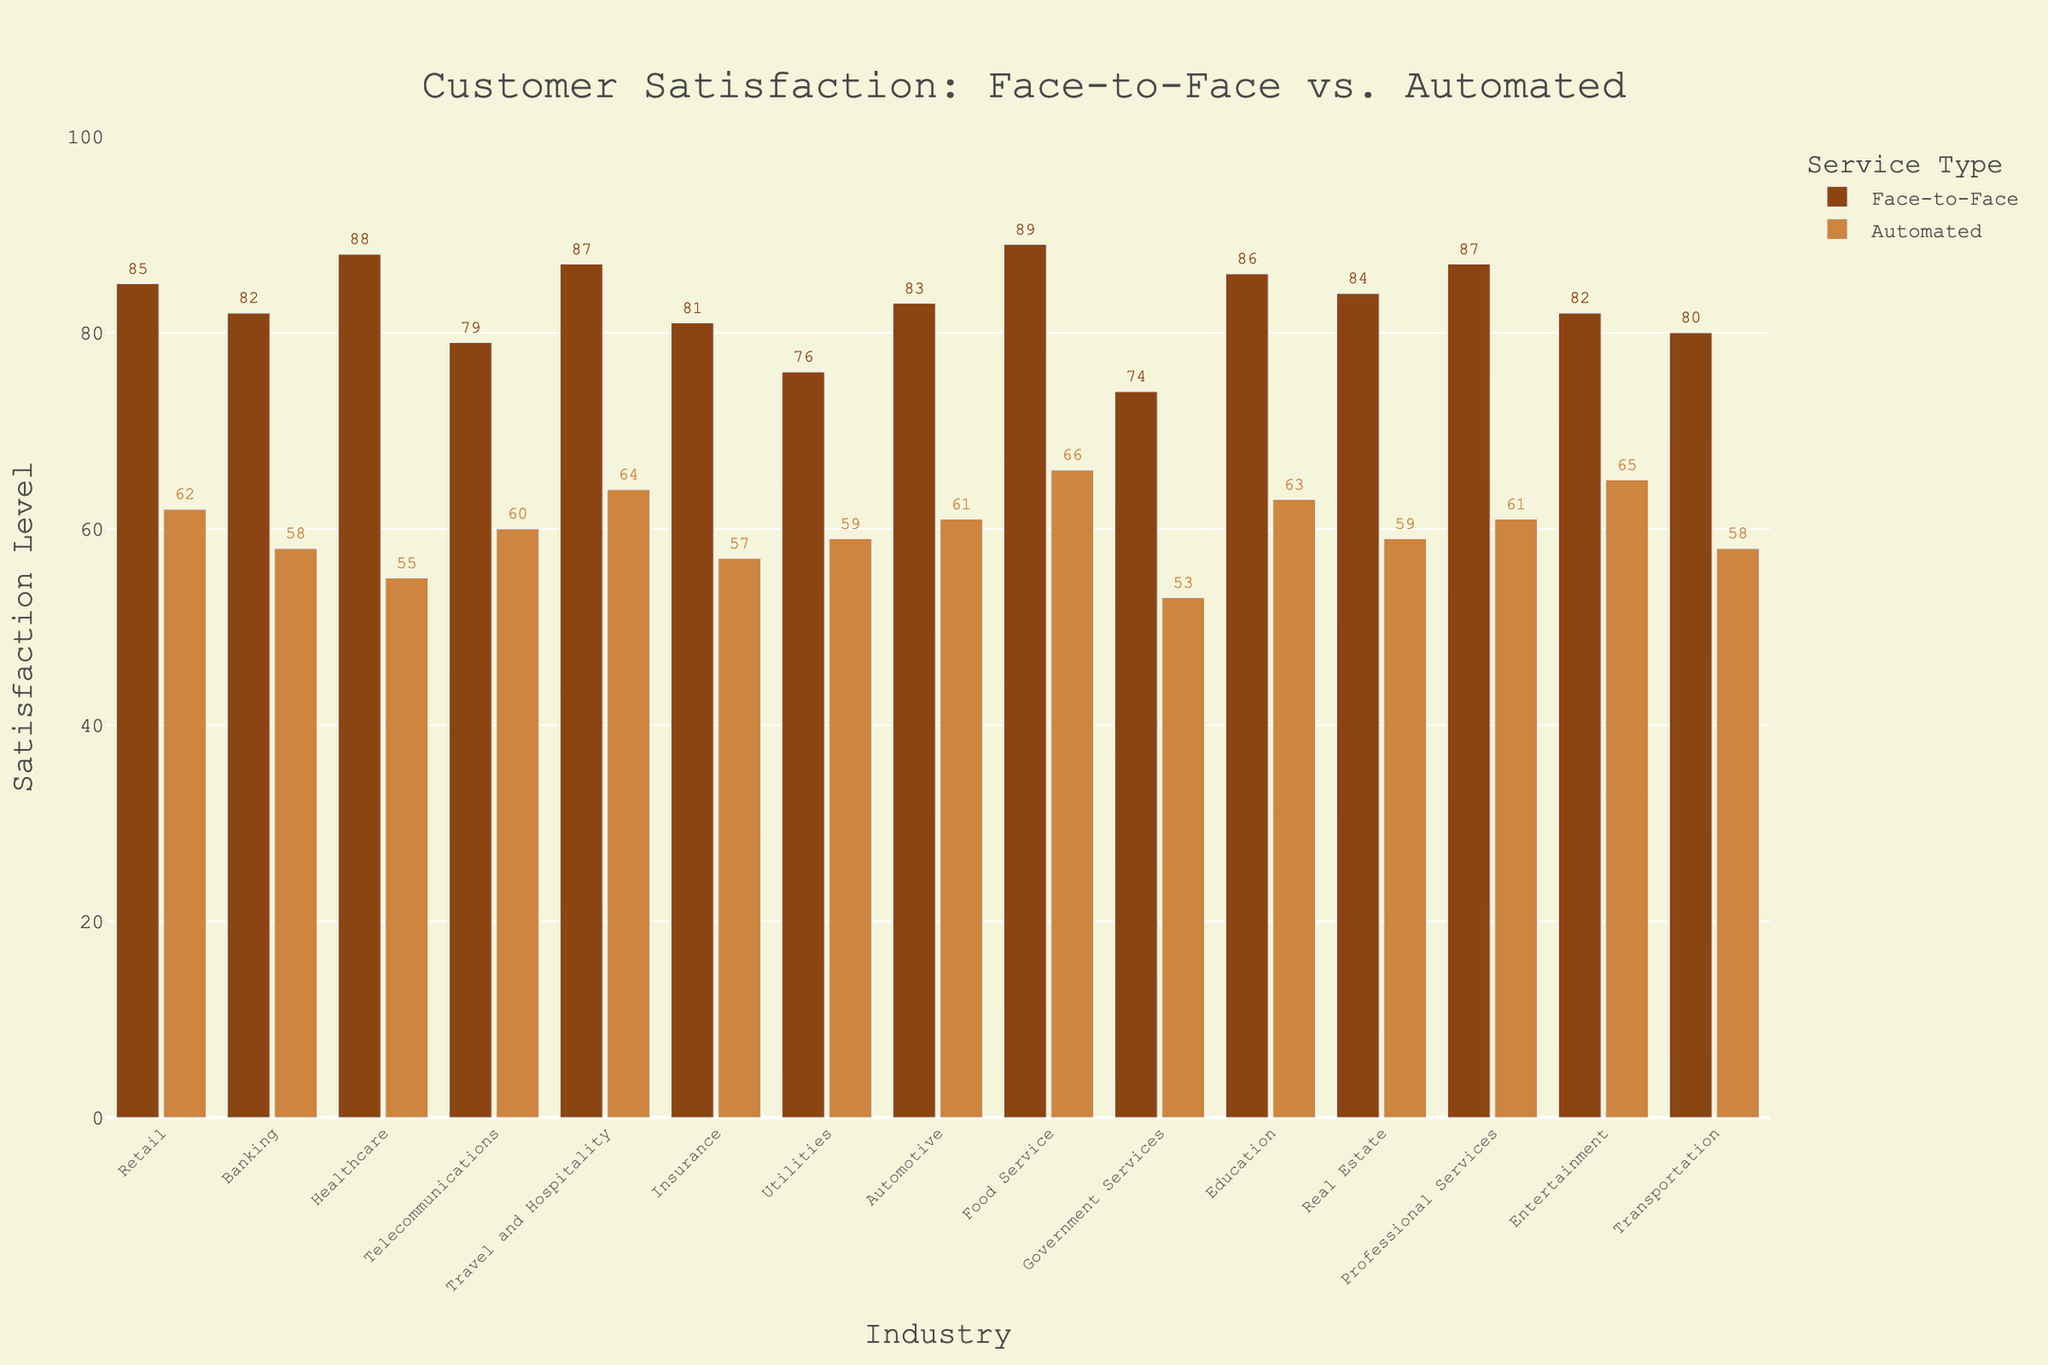Which industry has the highest face-to-face satisfaction level? The tallest bar in the face-to-face category represents the industry with the highest satisfaction level. The food service industry has the highest face-to-face satisfaction level at 89.
Answer: Food Service Which industry has the lowest automated satisfaction level? The shortest bar in the automated category represents the industry with the lowest satisfaction level. The government services industry has the lowest automated satisfaction level at 53.
Answer: Government Services What is the difference in satisfaction level between face-to-face and automated services for the healthcare industry? For healthcare, subtract the automated satisfaction value (55) from the face-to-face satisfaction value (88). 88 - 55 = 33.
Answer: 33 Which industry shows the smallest gap between face-to-face and automated satisfaction levels? Find the bars with the smallest visual difference in height between face-to-face and automated categories. The retail industry has a difference of only 23 points (85 - 62).
Answer: Retail Calculate the average face-to-face satisfaction across all industries represented in the chart. Add up all the face-to-face satisfaction values and divide by the number of industries: (85 + 82 + 88 + 79 + 87 + 81 + 76 + 83 + 89 + 74 + 86 + 84 + 87 + 82 + 80) / 15. This totals 1223 / 15 = 81.53.
Answer: 81.53 Which industry has a higher satisfaction level for automated services compared to its face-to-face services? Look for any industry where the automated bar is taller than the face-to-face bar. In this chart, no industry has higher automated satisfaction levels compared to face-to-face levels.
Answer: None What is the total satisfaction level combining both face-to-face and automated for the travel and hospitality industry? Sum the face-to-face satisfaction level (87) with the automated satisfaction level (64). 87 + 64 = 151.
Answer: 151 Identify the industry with the most visually striking difference between face-to-face and automated satisfaction. Look for the largest visual gap between the heights of the two bars. The healthcare industry has the most striking difference (88 face-to-face vs. 55 automated).
Answer: Healthcare Which industry has exactly a 20-point difference between face-to-face and automated satisfaction levels? Identify the industries where the difference between face-to-face and automated satisfaction is exactly 20. The automotive industry has face-to-face satisfaction of 83 and automated satisfaction of 61, resulting in an exact 22-point difference.
Answer: None 